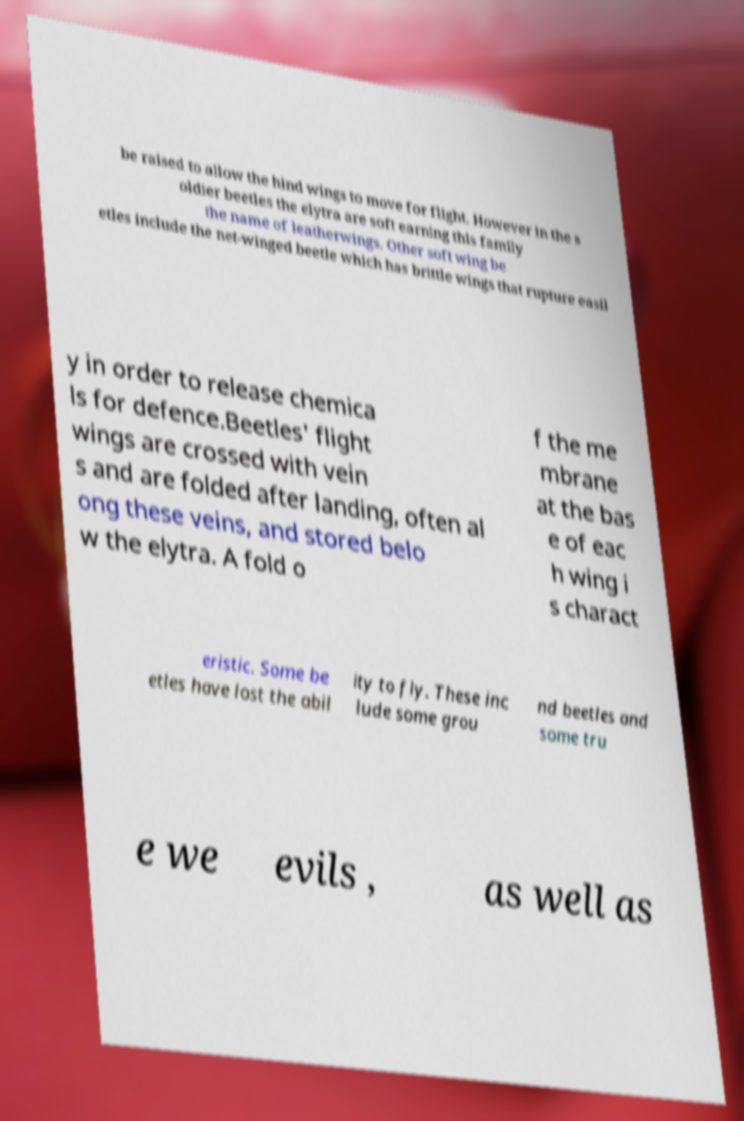Please identify and transcribe the text found in this image. be raised to allow the hind wings to move for flight. However in the s oldier beetles the elytra are soft earning this family the name of leatherwings. Other soft wing be etles include the net-winged beetle which has brittle wings that rupture easil y in order to release chemica ls for defence.Beetles' flight wings are crossed with vein s and are folded after landing, often al ong these veins, and stored belo w the elytra. A fold o f the me mbrane at the bas e of eac h wing i s charact eristic. Some be etles have lost the abil ity to fly. These inc lude some grou nd beetles and some tru e we evils , as well as 